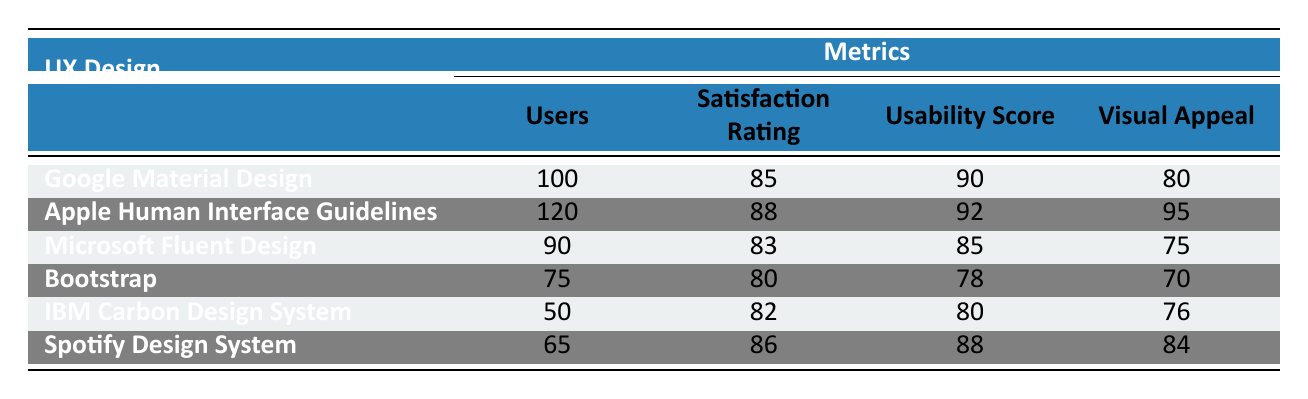What is the Satisfaction Rating for Bootstrap? The table displays the Satisfaction Rating for each UX Design under the corresponding "Satisfaction Rating" column. For Bootstrap, this rating is explicitly listed as 80.
Answer: 80 Which design has the highest Usability Score? To find the design with the highest Usability Score, we compare all the values listed in the "Usability Score" column. The highest score is 92 for the Apple Human Interface Guidelines.
Answer: Apple Human Interface Guidelines How many total users participated across all designs? To find the total number of users, we sum the "Users" column values: 100 + 120 + 90 + 75 + 50 + 65 = 500.
Answer: 500 Is the Visual Appeal of Microsoft Fluent Design higher than that of IBM Carbon Design System? By comparing the "Visual Appeal" values of both designs, Microsoft Fluent Design has a score of 75 and IBM Carbon Design System has a score of 76. Since 75 is less than 76, the statement is false.
Answer: No What is the average Satisfaction Rating of all the UX Designs? To calculate the average Satisfaction Rating, we sum the Satisfaction Ratings: 85 + 88 + 83 + 80 + 82 + 86 = 504 and divide by the number of designs (6). Thus, the average is 504 / 6 = 84.
Answer: 84 Which design has the lowest Visual Appeal? By looking at the "Visual Appeal" scores listed in the table, Bootstrap has the lowest score of 70.
Answer: Bootstrap How does the Satisfaction Rating of Spotify Design System compare to Microsoft Fluent Design? Spotify Design System has a Satisfaction Rating of 86, while Microsoft Fluent Design has a rating of 83. Since 86 is greater than 83, Spotify Design System has a higher rating.
Answer: Higher Is the total number of users for the Apple Human Interface Guidelines and the Spotify Design System greater than 200? The total users for both designs are 120 (Apple) + 65 (Spotify) = 185, which is less than 200.
Answer: No How many UX Designs have a Satisfaction Rating above 85? By examining the "Satisfaction Rating" column, we see that only two designs exceed a rating of 85: Apple Human Interface Guidelines (88) and Spotify Design System (86).
Answer: 2 